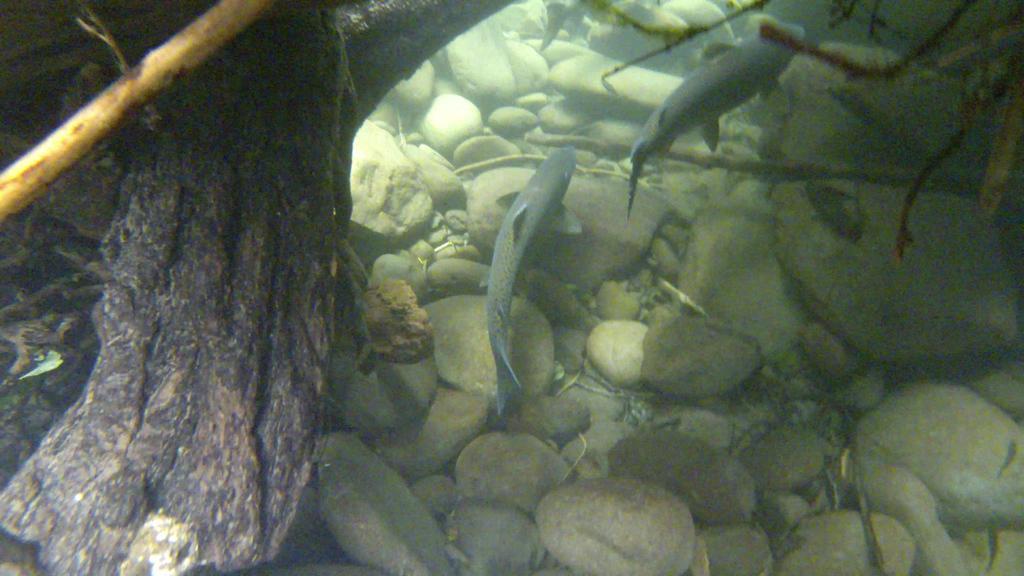Could you give a brief overview of what you see in this image? This image is taken inside the water. There are two fishes. At the bottom of the image there are stones. 